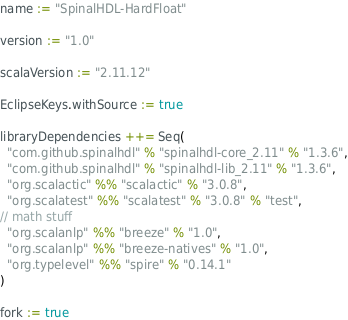<code> <loc_0><loc_0><loc_500><loc_500><_Scala_>name := "SpinalHDL-HardFloat"

version := "1.0"

scalaVersion := "2.11.12"

EclipseKeys.withSource := true

libraryDependencies ++= Seq(
  "com.github.spinalhdl" % "spinalhdl-core_2.11" % "1.3.6",
  "com.github.spinalhdl" % "spinalhdl-lib_2.11" % "1.3.6",
  "org.scalactic" %% "scalactic" % "3.0.8",
  "org.scalatest" %% "scalatest" % "3.0.8" % "test",  
// math stuff
  "org.scalanlp" %% "breeze" % "1.0",
  "org.scalanlp" %% "breeze-natives" % "1.0",
  "org.typelevel" %% "spire" % "0.14.1"
)

fork := true
</code> 